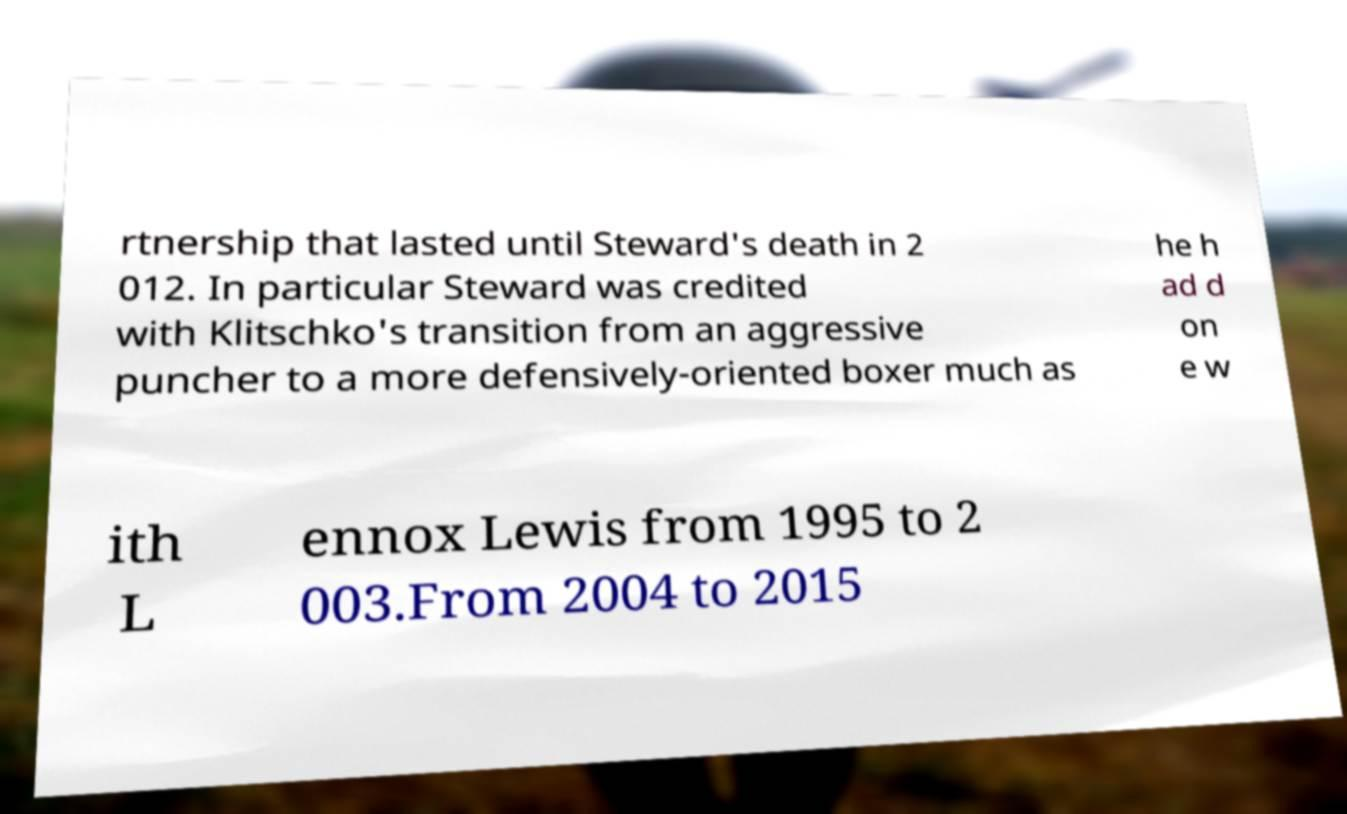I need the written content from this picture converted into text. Can you do that? rtnership that lasted until Steward's death in 2 012. In particular Steward was credited with Klitschko's transition from an aggressive puncher to a more defensively-oriented boxer much as he h ad d on e w ith L ennox Lewis from 1995 to 2 003.From 2004 to 2015 